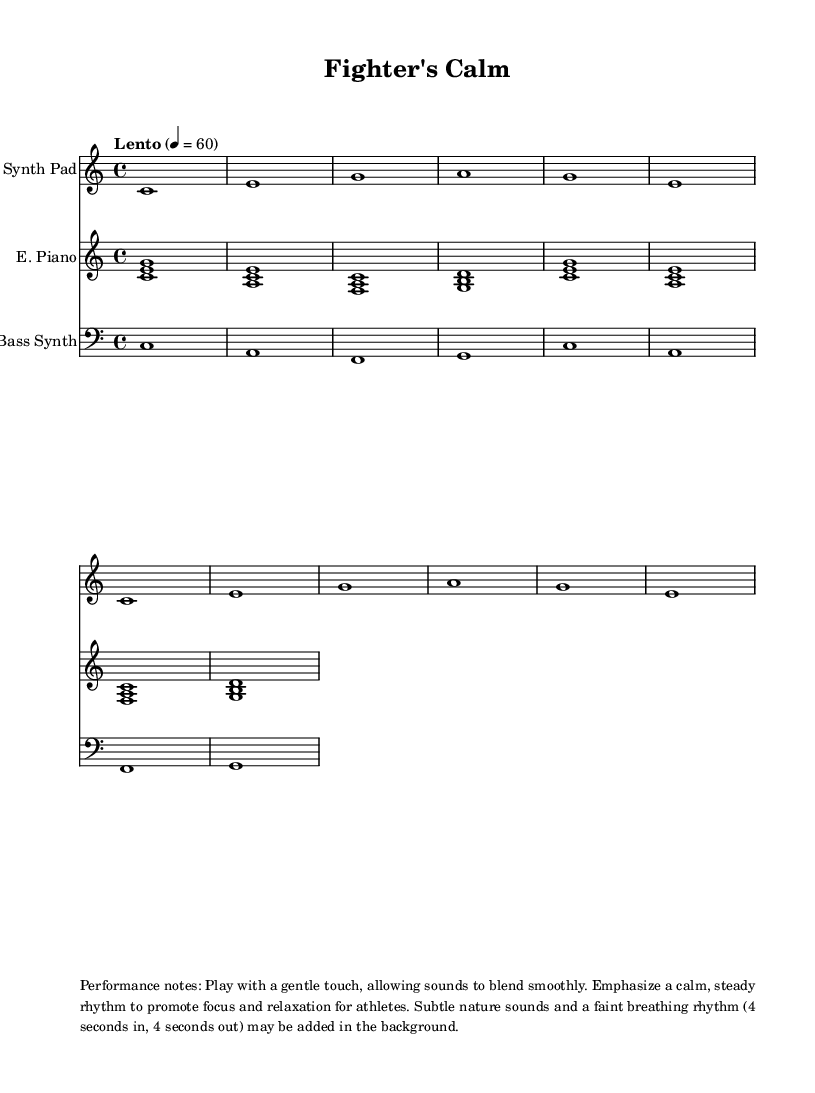What is the key signature of this music? The key signature is C major, which has no sharps or flats, indicated at the beginning of the score.
Answer: C major What is the time signature of this music? The time signature is 4/4, shown at the beginning of the score, indicating four beats per measure.
Answer: 4/4 What is the tempo marking of this music? The tempo marking is "Lento," which specifies a slow tempo, indicated above the staff with a mark of 60 beats per minute.
Answer: Lento How many measures are in the synth pad section? The synth pad section has 4 measures, as indicated by the repeating pattern and counting the notes in the provided music.
Answer: 4 Which instruments are used in this composition? The instruments are "Synth Pad," "E. Piano," and "Bass Synth," listed at the beginning of each staff in the score.
Answer: Synth Pad, E. Piano, Bass Synth What performance notes are provided for the musicians? The performance notes emphasize a gentle touch and a calm rhythm, along with suggestions to add nature sounds and a breathing rhythm, as described below the score.
Answer: Gentle touch, calm rhythm 